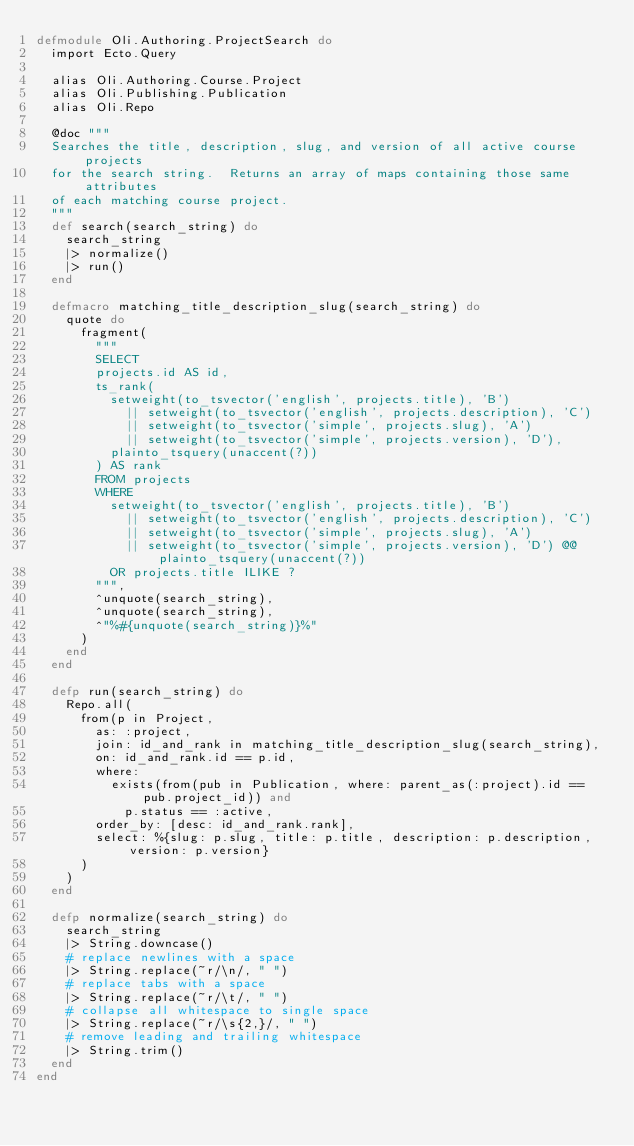Convert code to text. <code><loc_0><loc_0><loc_500><loc_500><_Elixir_>defmodule Oli.Authoring.ProjectSearch do
  import Ecto.Query

  alias Oli.Authoring.Course.Project
  alias Oli.Publishing.Publication
  alias Oli.Repo

  @doc """
  Searches the title, description, slug, and version of all active course projects
  for the search string.  Returns an array of maps containing those same attributes
  of each matching course project.
  """
  def search(search_string) do
    search_string
    |> normalize()
    |> run()
  end

  defmacro matching_title_description_slug(search_string) do
    quote do
      fragment(
        """
        SELECT
        projects.id AS id,
        ts_rank(
          setweight(to_tsvector('english', projects.title), 'B')
            || setweight(to_tsvector('english', projects.description), 'C')
            || setweight(to_tsvector('simple', projects.slug), 'A')
            || setweight(to_tsvector('simple', projects.version), 'D'),
          plainto_tsquery(unaccent(?))
        ) AS rank
        FROM projects
        WHERE
          setweight(to_tsvector('english', projects.title), 'B')
            || setweight(to_tsvector('english', projects.description), 'C')
            || setweight(to_tsvector('simple', projects.slug), 'A')
            || setweight(to_tsvector('simple', projects.version), 'D') @@ plainto_tsquery(unaccent(?))
          OR projects.title ILIKE ?
        """,
        ^unquote(search_string),
        ^unquote(search_string),
        ^"%#{unquote(search_string)}%"
      )
    end
  end

  defp run(search_string) do
    Repo.all(
      from(p in Project,
        as: :project,
        join: id_and_rank in matching_title_description_slug(search_string),
        on: id_and_rank.id == p.id,
        where:
          exists(from(pub in Publication, where: parent_as(:project).id == pub.project_id)) and
            p.status == :active,
        order_by: [desc: id_and_rank.rank],
        select: %{slug: p.slug, title: p.title, description: p.description, version: p.version}
      )
    )
  end

  defp normalize(search_string) do
    search_string
    |> String.downcase()
    # replace newlines with a space
    |> String.replace(~r/\n/, " ")
    # replace tabs with a space
    |> String.replace(~r/\t/, " ")
    # collapse all whitespace to single space
    |> String.replace(~r/\s{2,}/, " ")
    # remove leading and trailing whitespace
    |> String.trim()
  end
end
</code> 